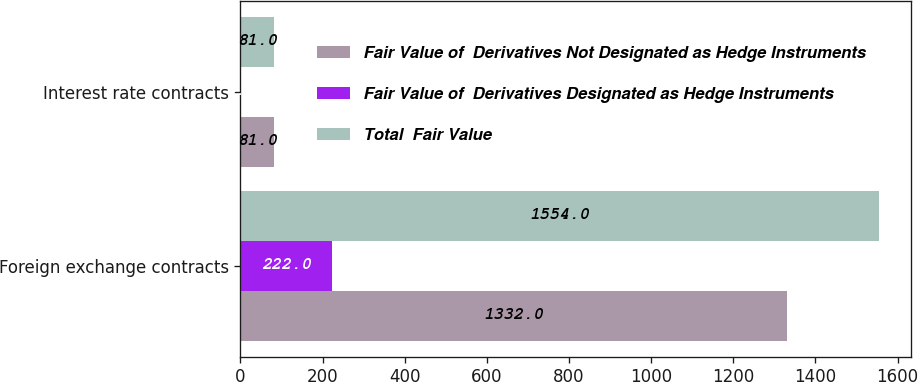Convert chart. <chart><loc_0><loc_0><loc_500><loc_500><stacked_bar_chart><ecel><fcel>Foreign exchange contracts<fcel>Interest rate contracts<nl><fcel>Fair Value of  Derivatives Not Designated as Hedge Instruments<fcel>1332<fcel>81<nl><fcel>Fair Value of  Derivatives Designated as Hedge Instruments<fcel>222<fcel>0<nl><fcel>Total  Fair Value<fcel>1554<fcel>81<nl></chart> 